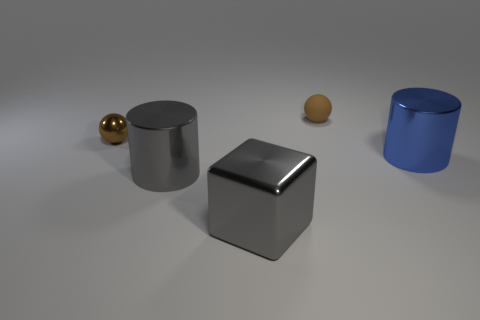Add 1 tiny green spheres. How many objects exist? 6 Subtract all cylinders. How many objects are left? 3 Add 4 tiny metal balls. How many tiny metal balls exist? 5 Subtract 0 cyan cylinders. How many objects are left? 5 Subtract all tiny balls. Subtract all metallic balls. How many objects are left? 2 Add 4 small brown balls. How many small brown balls are left? 6 